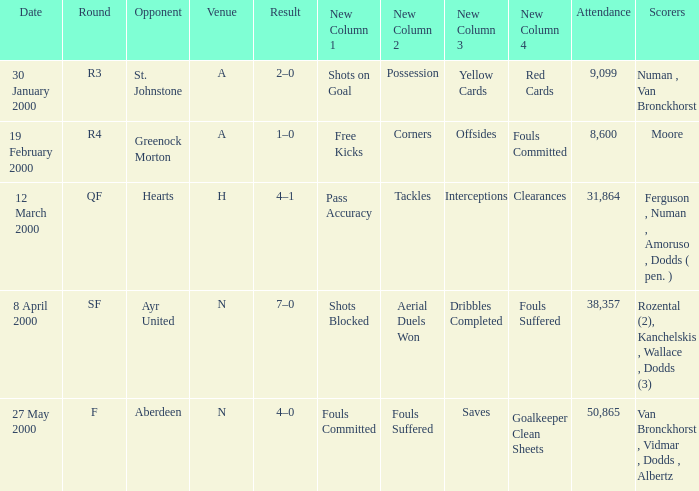Who was on 12 March 2000? Ferguson , Numan , Amoruso , Dodds ( pen. ). 